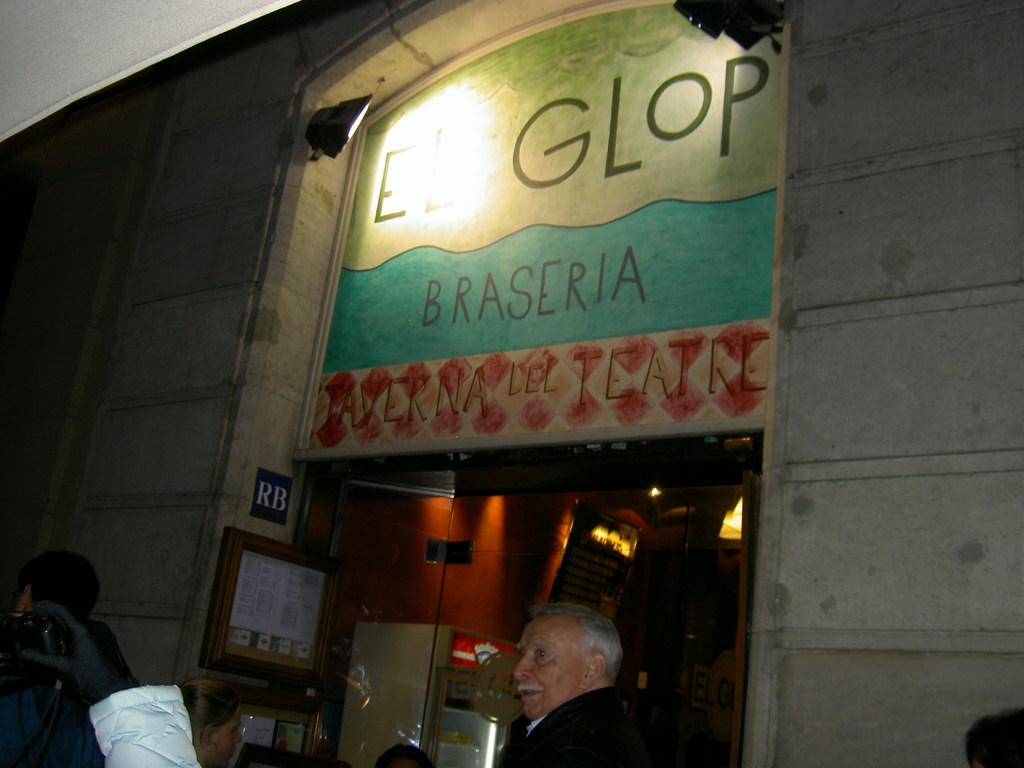What are the people in the image wearing? The people in the image are wearing clothes. Can you describe a specific part of a person's hand in the image? A human hand wearing a glove is visible in the image. What object is used to capture images in the image? A camera is present in the image. What can be seen written or printed in the image? There is text visible in the image. What type of illumination is present in the image? Lights are present in the image. What is a flat, rectangular object visible in the image? A board is visible in the image. What type of door is present in the image? A glass door is present in the image. How many bears are visible in the image? There are no bears present in the image. What type of crow is sitting on the camera in the image? There is no crow present in the image. 